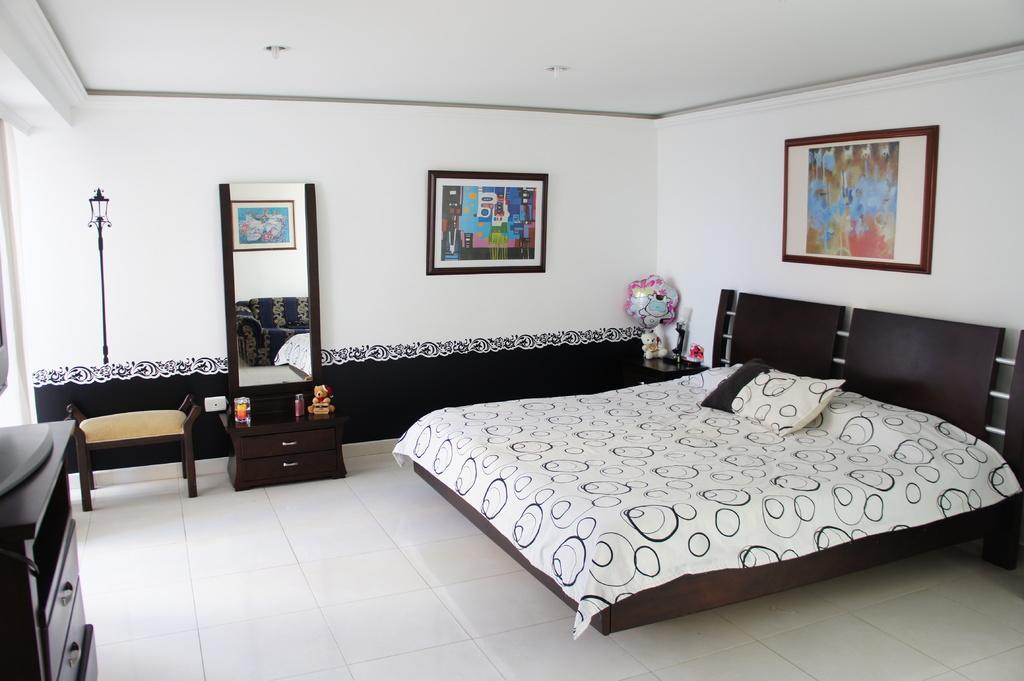Describe this image in one or two sentences. In this image I see a bed, drawers, as dressing table and a mirror on it and photo frames on the wall. 